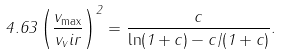Convert formula to latex. <formula><loc_0><loc_0><loc_500><loc_500>4 . 6 3 \left ( \frac { v _ { \max } } { v _ { v } i r } \right ) ^ { 2 } = \frac { c } { \ln ( 1 + c ) - c / ( 1 + c ) } .</formula> 